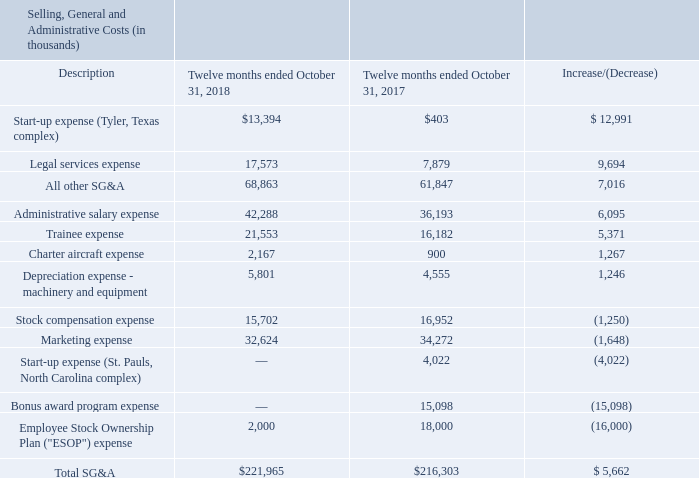SG&A costs during fiscal 2018 were $222.0 million, an increase of $5.7 million compared to the $216.3 million of SG&A during fiscal 2017. The following table shows the components of SG&A costs for the twelve months ended October 31, 2018 and 2017.
Regarding the table above, the change in start-up expense in any particular period relates to the stage of the start-up process in which a facility under construction is in during the period. Non-construction related expenses, such as labor, training and office-related expenses for a facility under construction are recorded as start-up expense until the facility begins operations. As a facility moves closer to actual start-up, the expenses incurred for labor, training, etc. increase. As a result, amounts classified as start-up expenses will increase period over period until the facility begins production. Once production begins, the expenses from that point forward are recorded as costs of goods sold. The increase in legal expenses was primarily attributable to our ongoing defense of the litigation described in “Part II, Item 3. Legal Proceedings” of this Form 10-K. The increases in trainee expense and administrative salaries were primarily attributable to increases in personnel that coincide with the Company's growth plans. The decrease in bonus expense, payouts of which are based on profitability, was the result of profitability not reaching the required levels for payout of that incentive. The decrease in ESOP expense, payouts of which are based on profitability, was attributable to the difference in the level of profitability between fiscal 2018 and 2017. The increase in all other SG&A expenses was the result of a net increase in various other categories of SG&A costs.
What is the legal service expenses for fiscal years 2018 and 2017 respectively?
Answer scale should be: thousand. 17,573, 7,879. What is the Administrative salary expense for fiscal years 2018 and 2017 respectively?
Answer scale should be: thousand. 42,288, 36,193. What does the table show? The components of sg&a costs for the twelve months ended october 31, 2018 and 2017. What is the average Charter aircraft expense for fiscal years 2018 and 2017?
Answer scale should be: thousand. (2,167+ 900)/2
Answer: 1533.5. What is the average Employee Stock Ownership Plan ("ESOP") expense for fiscal years 2018 and 2017?
Answer scale should be: thousand. (2,000+18,000)/2
Answer: 10000. What is the average Marketing expense for fiscal years 2018 and 2017?
Answer scale should be: thousand. (32,624+ 34,272)/2
Answer: 33448. 